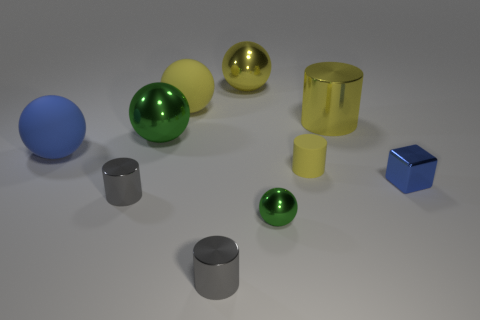Subtract all blue rubber balls. How many balls are left? 4 Subtract all blue spheres. How many spheres are left? 4 Subtract all cylinders. How many objects are left? 6 Add 4 big yellow metal cylinders. How many big yellow metal cylinders are left? 5 Add 9 tiny blue metallic things. How many tiny blue metallic things exist? 10 Subtract 1 blue balls. How many objects are left? 9 Subtract 2 cylinders. How many cylinders are left? 2 Subtract all purple cylinders. Subtract all blue blocks. How many cylinders are left? 4 Subtract all cyan spheres. How many yellow cylinders are left? 2 Subtract all tiny green matte cubes. Subtract all blue metallic blocks. How many objects are left? 9 